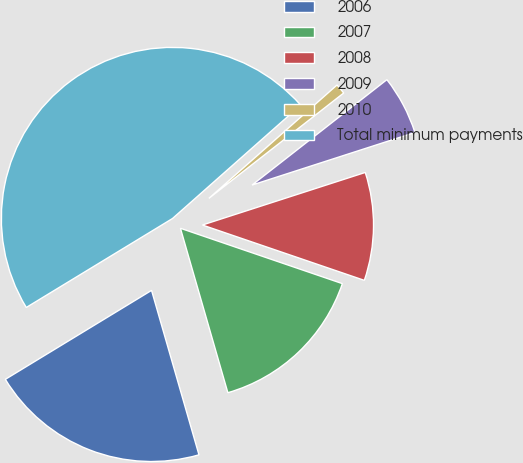Convert chart. <chart><loc_0><loc_0><loc_500><loc_500><pie_chart><fcel>2006<fcel>2007<fcel>2008<fcel>2009<fcel>2010<fcel>Total minimum payments<nl><fcel>20.77%<fcel>15.29%<fcel>10.21%<fcel>5.59%<fcel>0.97%<fcel>47.17%<nl></chart> 